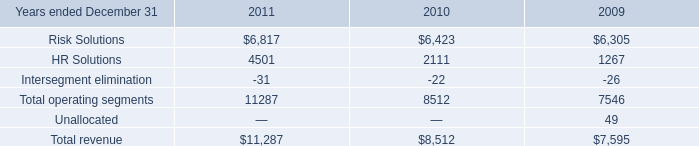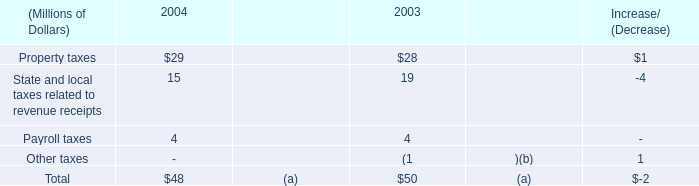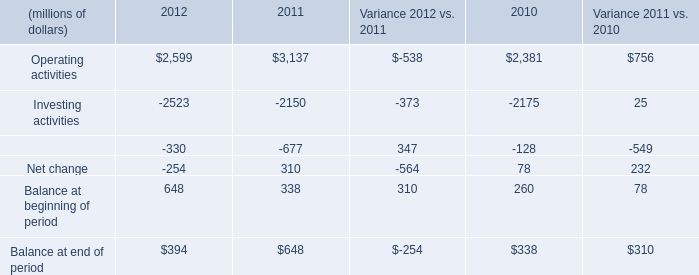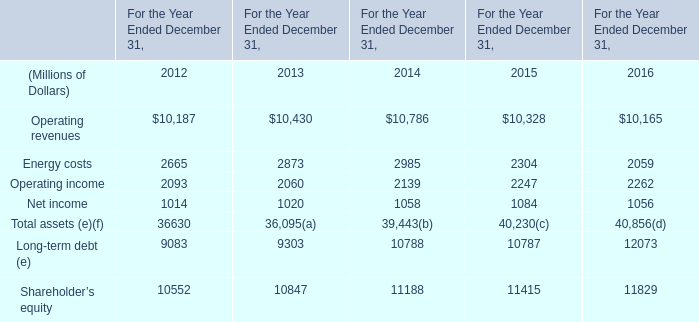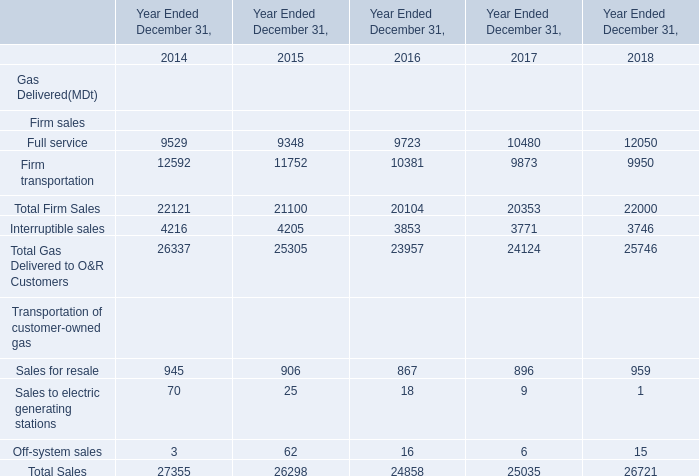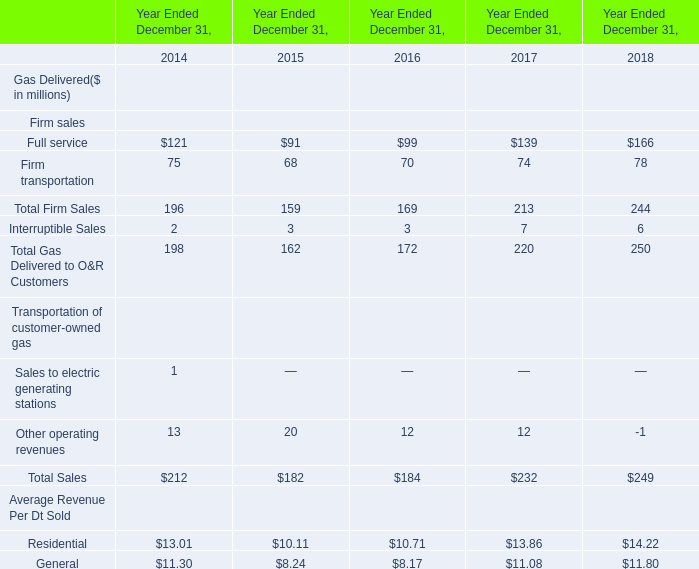What is the ratio of all elements that are smaller than 100 to the sum of elements in 2015? 
Computations: ((((((91 + 68) + 3) + 20) + 10.11) + 8.24) / ((((((((91 + 68) + 3) + 20) + 10.11) + 8.24) + 159) + 162) + 182))
Answer: 0.28485. 